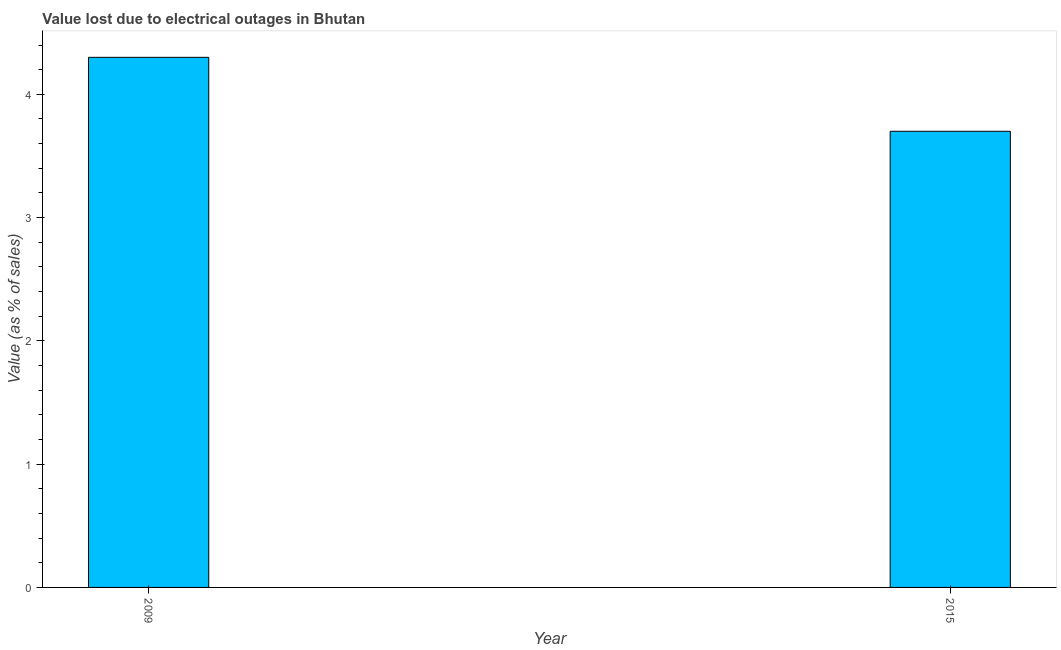What is the title of the graph?
Ensure brevity in your answer.  Value lost due to electrical outages in Bhutan. What is the label or title of the Y-axis?
Provide a succinct answer. Value (as % of sales). What is the value lost due to electrical outages in 2009?
Ensure brevity in your answer.  4.3. Across all years, what is the maximum value lost due to electrical outages?
Offer a very short reply. 4.3. In which year was the value lost due to electrical outages minimum?
Give a very brief answer. 2015. What is the sum of the value lost due to electrical outages?
Keep it short and to the point. 8. What is the difference between the value lost due to electrical outages in 2009 and 2015?
Offer a very short reply. 0.6. What is the average value lost due to electrical outages per year?
Provide a succinct answer. 4. What is the median value lost due to electrical outages?
Offer a very short reply. 4. In how many years, is the value lost due to electrical outages greater than 2.6 %?
Provide a short and direct response. 2. What is the ratio of the value lost due to electrical outages in 2009 to that in 2015?
Provide a short and direct response. 1.16. Is the value lost due to electrical outages in 2009 less than that in 2015?
Your answer should be very brief. No. Are all the bars in the graph horizontal?
Keep it short and to the point. No. What is the difference between two consecutive major ticks on the Y-axis?
Your answer should be very brief. 1. Are the values on the major ticks of Y-axis written in scientific E-notation?
Offer a very short reply. No. What is the Value (as % of sales) in 2015?
Make the answer very short. 3.7. What is the ratio of the Value (as % of sales) in 2009 to that in 2015?
Make the answer very short. 1.16. 